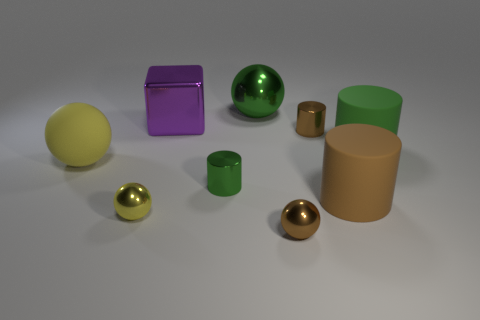Which objects in the image are reflective? The metal spheres and the purple cube are reflective. You can see their shiny surfaces catching the light differently compared to the more matte finish of the other objects.  Could you describe the texture of the green objects? The green objects seem to have a smooth, matte texture, which suggests they could be made of rubber or a similarly non-reflective material. 